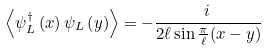<formula> <loc_0><loc_0><loc_500><loc_500>\left \langle { \psi _ { L } ^ { \dagger } \left ( x \right ) \psi _ { L } \left ( y \right ) } \right \rangle = - \frac { i \, } { { 2 \ell \sin \frac { \pi } { \ell } ( x - y ) } }</formula> 